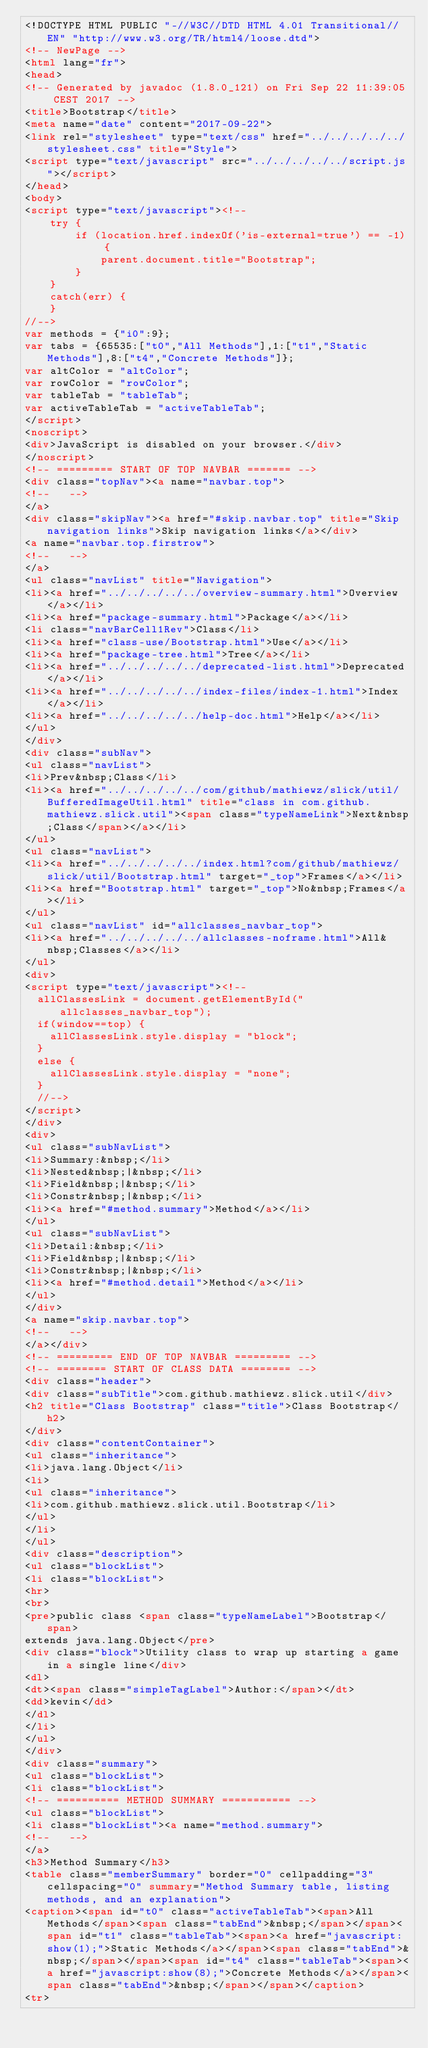<code> <loc_0><loc_0><loc_500><loc_500><_HTML_><!DOCTYPE HTML PUBLIC "-//W3C//DTD HTML 4.01 Transitional//EN" "http://www.w3.org/TR/html4/loose.dtd">
<!-- NewPage -->
<html lang="fr">
<head>
<!-- Generated by javadoc (1.8.0_121) on Fri Sep 22 11:39:05 CEST 2017 -->
<title>Bootstrap</title>
<meta name="date" content="2017-09-22">
<link rel="stylesheet" type="text/css" href="../../../../../stylesheet.css" title="Style">
<script type="text/javascript" src="../../../../../script.js"></script>
</head>
<body>
<script type="text/javascript"><!--
    try {
        if (location.href.indexOf('is-external=true') == -1) {
            parent.document.title="Bootstrap";
        }
    }
    catch(err) {
    }
//-->
var methods = {"i0":9};
var tabs = {65535:["t0","All Methods"],1:["t1","Static Methods"],8:["t4","Concrete Methods"]};
var altColor = "altColor";
var rowColor = "rowColor";
var tableTab = "tableTab";
var activeTableTab = "activeTableTab";
</script>
<noscript>
<div>JavaScript is disabled on your browser.</div>
</noscript>
<!-- ========= START OF TOP NAVBAR ======= -->
<div class="topNav"><a name="navbar.top">
<!--   -->
</a>
<div class="skipNav"><a href="#skip.navbar.top" title="Skip navigation links">Skip navigation links</a></div>
<a name="navbar.top.firstrow">
<!--   -->
</a>
<ul class="navList" title="Navigation">
<li><a href="../../../../../overview-summary.html">Overview</a></li>
<li><a href="package-summary.html">Package</a></li>
<li class="navBarCell1Rev">Class</li>
<li><a href="class-use/Bootstrap.html">Use</a></li>
<li><a href="package-tree.html">Tree</a></li>
<li><a href="../../../../../deprecated-list.html">Deprecated</a></li>
<li><a href="../../../../../index-files/index-1.html">Index</a></li>
<li><a href="../../../../../help-doc.html">Help</a></li>
</ul>
</div>
<div class="subNav">
<ul class="navList">
<li>Prev&nbsp;Class</li>
<li><a href="../../../../../com/github/mathiewz/slick/util/BufferedImageUtil.html" title="class in com.github.mathiewz.slick.util"><span class="typeNameLink">Next&nbsp;Class</span></a></li>
</ul>
<ul class="navList">
<li><a href="../../../../../index.html?com/github/mathiewz/slick/util/Bootstrap.html" target="_top">Frames</a></li>
<li><a href="Bootstrap.html" target="_top">No&nbsp;Frames</a></li>
</ul>
<ul class="navList" id="allclasses_navbar_top">
<li><a href="../../../../../allclasses-noframe.html">All&nbsp;Classes</a></li>
</ul>
<div>
<script type="text/javascript"><!--
  allClassesLink = document.getElementById("allclasses_navbar_top");
  if(window==top) {
    allClassesLink.style.display = "block";
  }
  else {
    allClassesLink.style.display = "none";
  }
  //-->
</script>
</div>
<div>
<ul class="subNavList">
<li>Summary:&nbsp;</li>
<li>Nested&nbsp;|&nbsp;</li>
<li>Field&nbsp;|&nbsp;</li>
<li>Constr&nbsp;|&nbsp;</li>
<li><a href="#method.summary">Method</a></li>
</ul>
<ul class="subNavList">
<li>Detail:&nbsp;</li>
<li>Field&nbsp;|&nbsp;</li>
<li>Constr&nbsp;|&nbsp;</li>
<li><a href="#method.detail">Method</a></li>
</ul>
</div>
<a name="skip.navbar.top">
<!--   -->
</a></div>
<!-- ========= END OF TOP NAVBAR ========= -->
<!-- ======== START OF CLASS DATA ======== -->
<div class="header">
<div class="subTitle">com.github.mathiewz.slick.util</div>
<h2 title="Class Bootstrap" class="title">Class Bootstrap</h2>
</div>
<div class="contentContainer">
<ul class="inheritance">
<li>java.lang.Object</li>
<li>
<ul class="inheritance">
<li>com.github.mathiewz.slick.util.Bootstrap</li>
</ul>
</li>
</ul>
<div class="description">
<ul class="blockList">
<li class="blockList">
<hr>
<br>
<pre>public class <span class="typeNameLabel">Bootstrap</span>
extends java.lang.Object</pre>
<div class="block">Utility class to wrap up starting a game in a single line</div>
<dl>
<dt><span class="simpleTagLabel">Author:</span></dt>
<dd>kevin</dd>
</dl>
</li>
</ul>
</div>
<div class="summary">
<ul class="blockList">
<li class="blockList">
<!-- ========== METHOD SUMMARY =========== -->
<ul class="blockList">
<li class="blockList"><a name="method.summary">
<!--   -->
</a>
<h3>Method Summary</h3>
<table class="memberSummary" border="0" cellpadding="3" cellspacing="0" summary="Method Summary table, listing methods, and an explanation">
<caption><span id="t0" class="activeTableTab"><span>All Methods</span><span class="tabEnd">&nbsp;</span></span><span id="t1" class="tableTab"><span><a href="javascript:show(1);">Static Methods</a></span><span class="tabEnd">&nbsp;</span></span><span id="t4" class="tableTab"><span><a href="javascript:show(8);">Concrete Methods</a></span><span class="tabEnd">&nbsp;</span></span></caption>
<tr></code> 